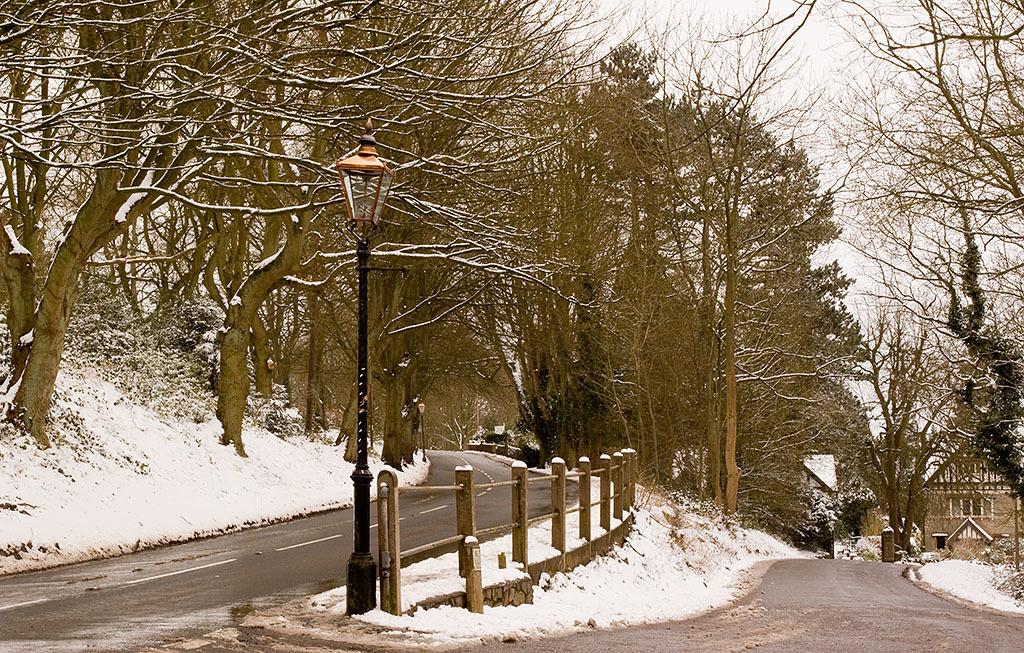What type of vegetation can be seen in the image? There are trees in the image. What type of pathway is present in the image? There is a road in the image. What type of barrier is present in the image? There is a wooden fence in the image. What type of structure is visible in the distance? A house is visible in the distance. What is covering the ground in the image? There is snow on the ground. What type of lighting is present in the image? There is a light with a pole in the image. How many pairs of underwear can be seen hanging on the trees in the image? There are no underwear visible in the image; it features trees, a road, a wooden fence, a house in the distance, snow on the ground, and a light with a pole. How many planes are flying over the trees in the image? There are no planes visible in the image; it features trees, a road, a wooden fence, a house in the distance, snow on the ground, and a light with a pole. 